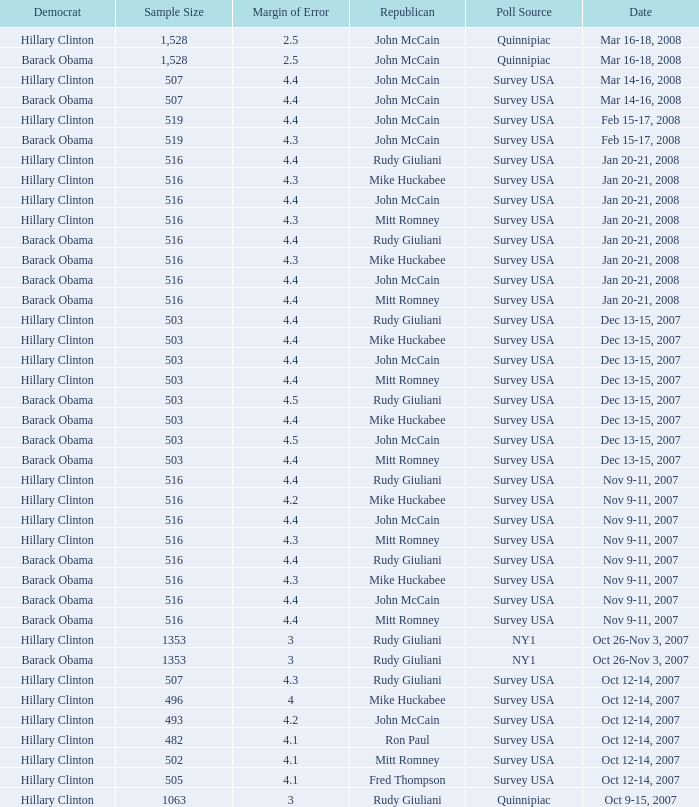What was the date of the poll with a sample size of 496 where Republican Mike Huckabee was chosen? Oct 12-14, 2007. 